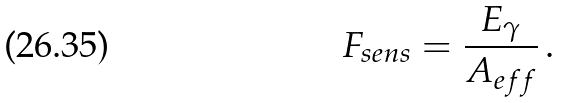Convert formula to latex. <formula><loc_0><loc_0><loc_500><loc_500>F _ { s e n s } = \frac { E _ { \gamma } } { A _ { e f f } } \, .</formula> 